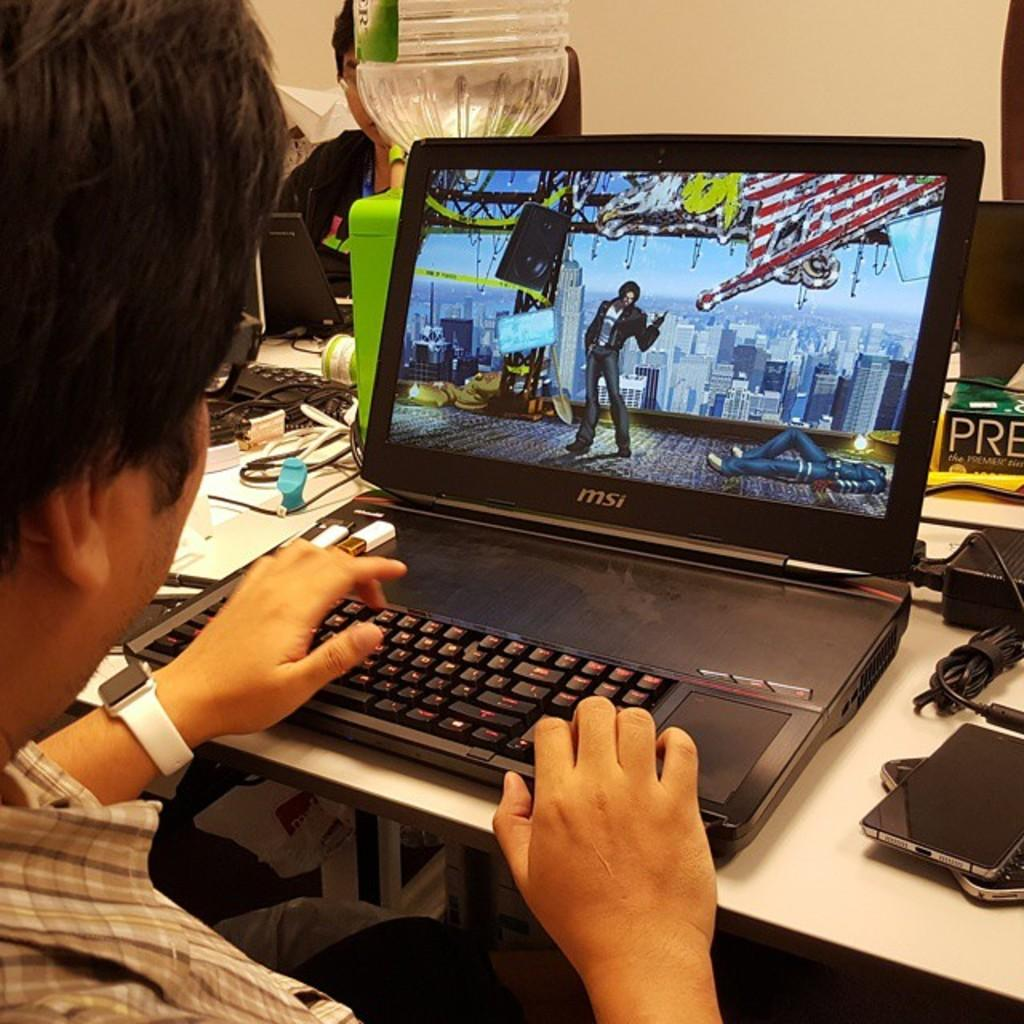Provide a one-sentence caption for the provided image. A man is working on a MSI black laptop. 